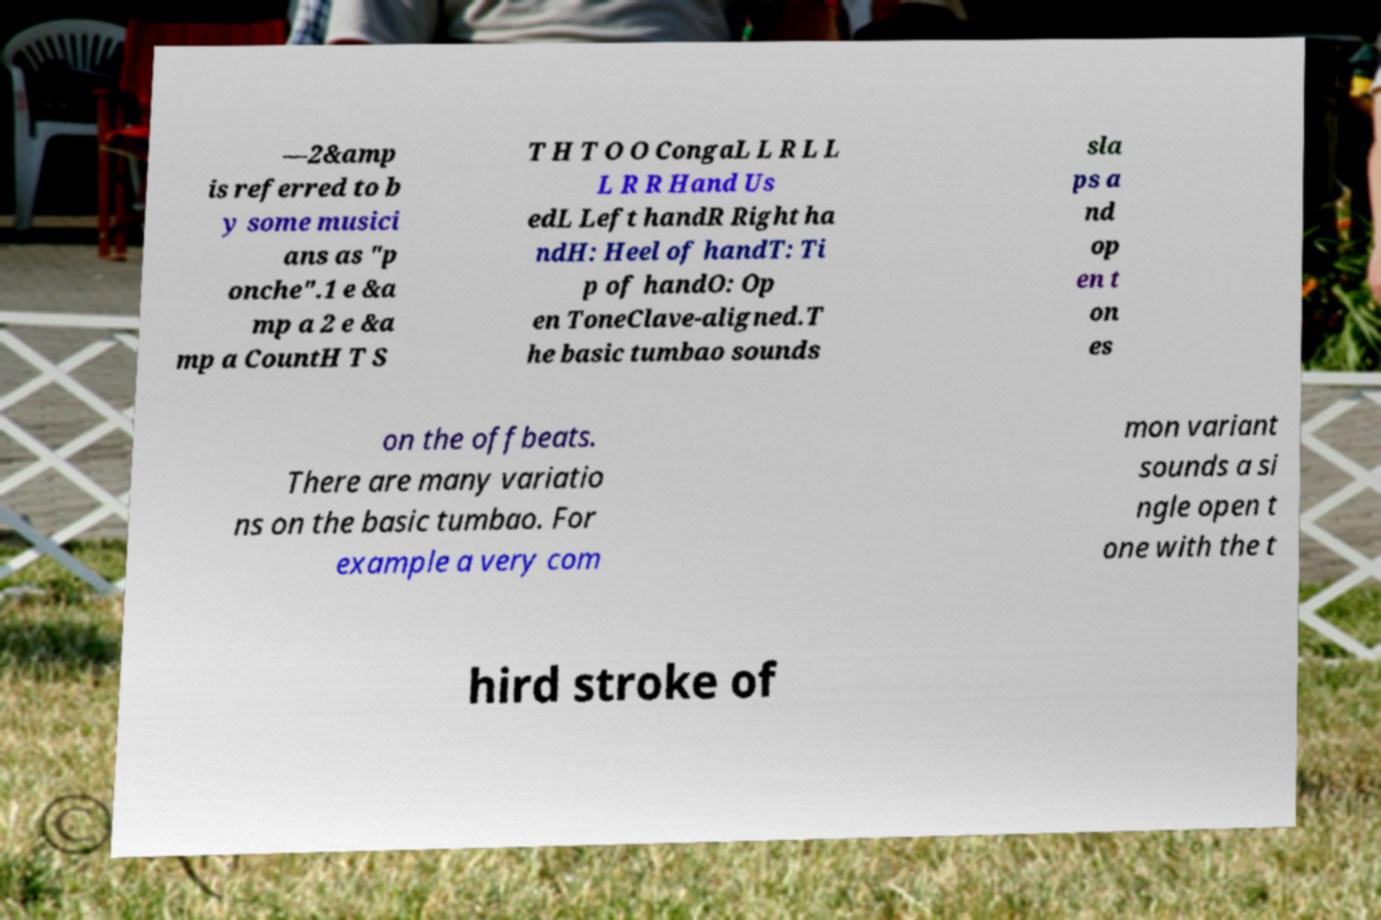Could you assist in decoding the text presented in this image and type it out clearly? —2&amp is referred to b y some musici ans as "p onche".1 e &a mp a 2 e &a mp a CountH T S T H T O O CongaL L R L L L R R Hand Us edL Left handR Right ha ndH: Heel of handT: Ti p of handO: Op en ToneClave-aligned.T he basic tumbao sounds sla ps a nd op en t on es on the offbeats. There are many variatio ns on the basic tumbao. For example a very com mon variant sounds a si ngle open t one with the t hird stroke of 